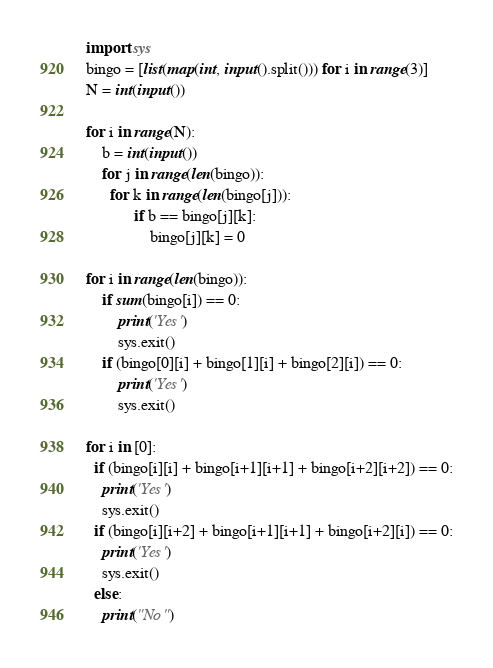<code> <loc_0><loc_0><loc_500><loc_500><_Python_>import sys
bingo = [list(map(int, input().split())) for i in range(3)]
N = int(input())

for i in range(N):
    b = int(input())
    for j in range(len(bingo)):
      for k in range(len(bingo[j])):
            if b == bingo[j][k]:
                bingo[j][k] = 0

for i in range(len(bingo)):
    if sum(bingo[i]) == 0:
        print('Yes')
        sys.exit()
    if (bingo[0][i] + bingo[1][i] + bingo[2][i]) == 0:
        print('Yes')
        sys.exit()

for i in [0]:
  if (bingo[i][i] + bingo[i+1][i+1] + bingo[i+2][i+2]) == 0:
    print('Yes')
    sys.exit()
  if (bingo[i][i+2] + bingo[i+1][i+1] + bingo[i+2][i]) == 0:
    print('Yes')
    sys.exit()
  else:
    print("No")</code> 